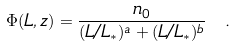Convert formula to latex. <formula><loc_0><loc_0><loc_500><loc_500>\Phi ( L , z ) = \frac { n _ { 0 } } { ( L / L _ { \ast } ) ^ { a } + ( L / L _ { \ast } ) ^ { b } } \ .</formula> 